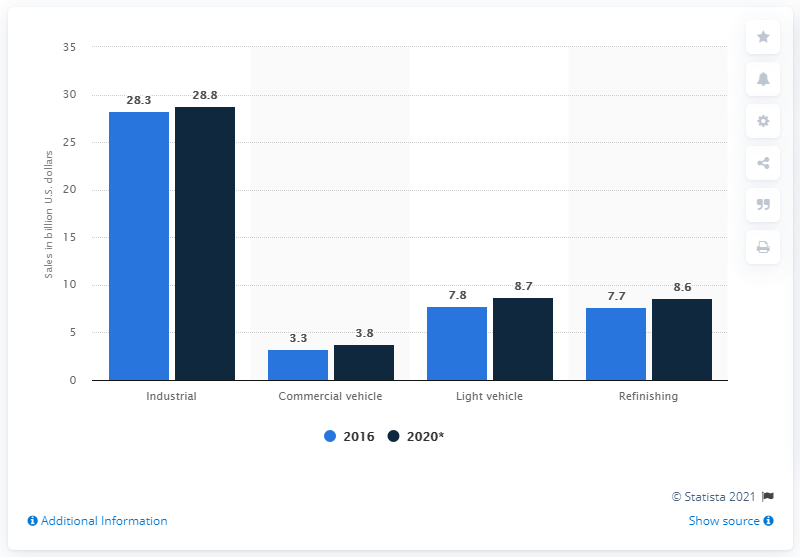List a handful of essential elements in this visual. In 2016, the global sales of coatings used for industrial purposes were approximately 28.3 billion dollars. According to our projections, coatings sales are expected to increase by 28.8% in 2020 compared to the previous year. 